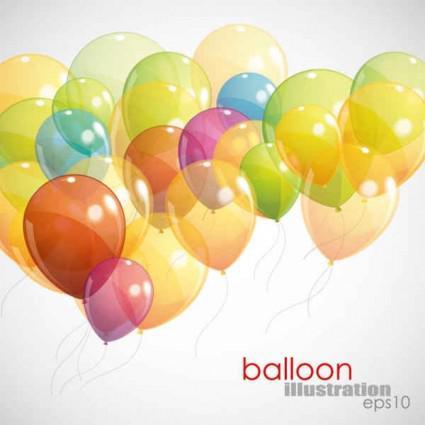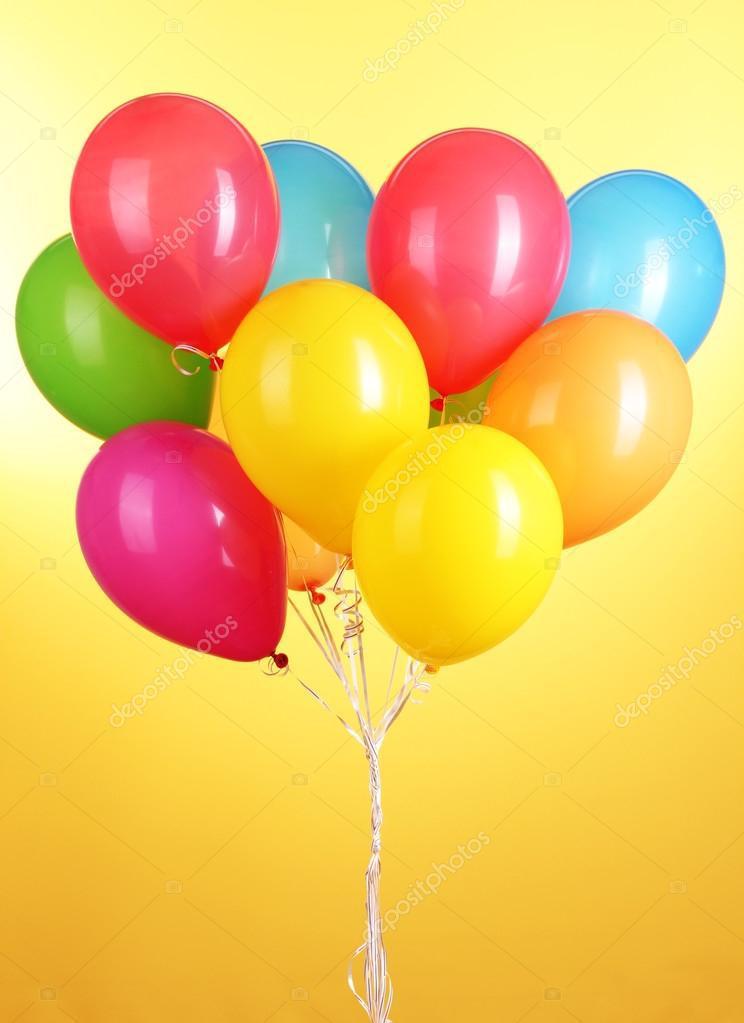The first image is the image on the left, the second image is the image on the right. Given the left and right images, does the statement "One image shows a bunch of balloons with gathered strings and curly ribbons under it, and the other image shows balloons trailing loose strings that don't hang straight." hold true? Answer yes or no. Yes. The first image is the image on the left, the second image is the image on the right. Analyze the images presented: Is the assertion "in at least one image there are at least fifteen loose balloons on strings." valid? Answer yes or no. Yes. 